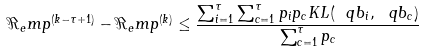Convert formula to latex. <formula><loc_0><loc_0><loc_500><loc_500>\Re _ { e } m p ^ { ( k - \tau + 1 ) } - \Re _ { e } m p ^ { ( k ) } \leq \frac { \sum _ { i = 1 } ^ { \tau } \sum _ { c = 1 } ^ { \tau } p _ { i } p _ { c } K L ( \ q b _ { i } , \ q b _ { c } ) } { \sum _ { c = 1 } ^ { \tau } p _ { c } }</formula> 